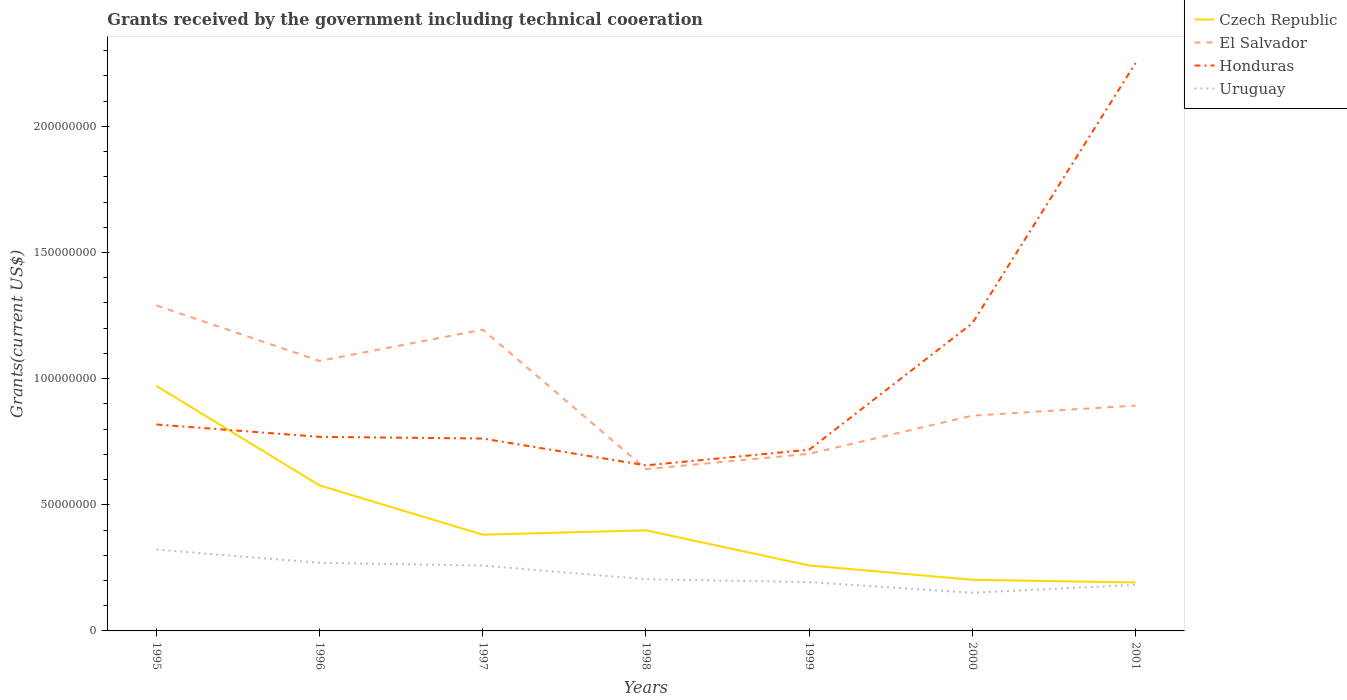How many different coloured lines are there?
Your answer should be compact. 4. Across all years, what is the maximum total grants received by the government in Honduras?
Ensure brevity in your answer.  6.56e+07. What is the total total grants received by the government in Honduras in the graph?
Keep it short and to the point. -6.20e+06. What is the difference between the highest and the second highest total grants received by the government in Czech Republic?
Make the answer very short. 7.79e+07. Is the total grants received by the government in El Salvador strictly greater than the total grants received by the government in Czech Republic over the years?
Give a very brief answer. No. How many years are there in the graph?
Offer a terse response. 7. What is the difference between two consecutive major ticks on the Y-axis?
Keep it short and to the point. 5.00e+07. Does the graph contain any zero values?
Provide a succinct answer. No. Where does the legend appear in the graph?
Provide a succinct answer. Top right. What is the title of the graph?
Provide a succinct answer. Grants received by the government including technical cooeration. Does "Haiti" appear as one of the legend labels in the graph?
Make the answer very short. No. What is the label or title of the X-axis?
Provide a succinct answer. Years. What is the label or title of the Y-axis?
Ensure brevity in your answer.  Grants(current US$). What is the Grants(current US$) in Czech Republic in 1995?
Your answer should be very brief. 9.71e+07. What is the Grants(current US$) in El Salvador in 1995?
Your answer should be compact. 1.29e+08. What is the Grants(current US$) in Honduras in 1995?
Provide a short and direct response. 8.18e+07. What is the Grants(current US$) in Uruguay in 1995?
Ensure brevity in your answer.  3.22e+07. What is the Grants(current US$) in Czech Republic in 1996?
Provide a short and direct response. 5.77e+07. What is the Grants(current US$) of El Salvador in 1996?
Keep it short and to the point. 1.07e+08. What is the Grants(current US$) in Honduras in 1996?
Provide a short and direct response. 7.69e+07. What is the Grants(current US$) in Uruguay in 1996?
Offer a very short reply. 2.70e+07. What is the Grants(current US$) of Czech Republic in 1997?
Your answer should be compact. 3.81e+07. What is the Grants(current US$) of El Salvador in 1997?
Offer a terse response. 1.19e+08. What is the Grants(current US$) in Honduras in 1997?
Provide a succinct answer. 7.63e+07. What is the Grants(current US$) in Uruguay in 1997?
Provide a short and direct response. 2.59e+07. What is the Grants(current US$) of Czech Republic in 1998?
Ensure brevity in your answer.  3.99e+07. What is the Grants(current US$) of El Salvador in 1998?
Provide a succinct answer. 6.41e+07. What is the Grants(current US$) of Honduras in 1998?
Your response must be concise. 6.56e+07. What is the Grants(current US$) in Uruguay in 1998?
Provide a short and direct response. 2.05e+07. What is the Grants(current US$) in Czech Republic in 1999?
Your response must be concise. 2.60e+07. What is the Grants(current US$) in El Salvador in 1999?
Keep it short and to the point. 7.02e+07. What is the Grants(current US$) in Honduras in 1999?
Offer a terse response. 7.18e+07. What is the Grants(current US$) of Uruguay in 1999?
Offer a very short reply. 1.94e+07. What is the Grants(current US$) in Czech Republic in 2000?
Make the answer very short. 2.03e+07. What is the Grants(current US$) in El Salvador in 2000?
Your answer should be very brief. 8.53e+07. What is the Grants(current US$) of Honduras in 2000?
Keep it short and to the point. 1.22e+08. What is the Grants(current US$) in Uruguay in 2000?
Your response must be concise. 1.51e+07. What is the Grants(current US$) of Czech Republic in 2001?
Make the answer very short. 1.92e+07. What is the Grants(current US$) of El Salvador in 2001?
Provide a short and direct response. 8.93e+07. What is the Grants(current US$) of Honduras in 2001?
Your answer should be compact. 2.25e+08. What is the Grants(current US$) of Uruguay in 2001?
Keep it short and to the point. 1.83e+07. Across all years, what is the maximum Grants(current US$) of Czech Republic?
Make the answer very short. 9.71e+07. Across all years, what is the maximum Grants(current US$) in El Salvador?
Provide a succinct answer. 1.29e+08. Across all years, what is the maximum Grants(current US$) in Honduras?
Ensure brevity in your answer.  2.25e+08. Across all years, what is the maximum Grants(current US$) in Uruguay?
Your answer should be compact. 3.22e+07. Across all years, what is the minimum Grants(current US$) in Czech Republic?
Provide a succinct answer. 1.92e+07. Across all years, what is the minimum Grants(current US$) in El Salvador?
Your answer should be compact. 6.41e+07. Across all years, what is the minimum Grants(current US$) of Honduras?
Keep it short and to the point. 6.56e+07. Across all years, what is the minimum Grants(current US$) in Uruguay?
Ensure brevity in your answer.  1.51e+07. What is the total Grants(current US$) of Czech Republic in the graph?
Your answer should be very brief. 2.98e+08. What is the total Grants(current US$) in El Salvador in the graph?
Make the answer very short. 6.64e+08. What is the total Grants(current US$) in Honduras in the graph?
Your response must be concise. 7.20e+08. What is the total Grants(current US$) in Uruguay in the graph?
Your answer should be compact. 1.58e+08. What is the difference between the Grants(current US$) in Czech Republic in 1995 and that in 1996?
Offer a terse response. 3.94e+07. What is the difference between the Grants(current US$) of El Salvador in 1995 and that in 1996?
Ensure brevity in your answer.  2.20e+07. What is the difference between the Grants(current US$) of Honduras in 1995 and that in 1996?
Offer a very short reply. 4.89e+06. What is the difference between the Grants(current US$) in Uruguay in 1995 and that in 1996?
Your answer should be very brief. 5.24e+06. What is the difference between the Grants(current US$) in Czech Republic in 1995 and that in 1997?
Give a very brief answer. 5.90e+07. What is the difference between the Grants(current US$) of El Salvador in 1995 and that in 1997?
Your answer should be compact. 9.61e+06. What is the difference between the Grants(current US$) in Honduras in 1995 and that in 1997?
Your answer should be compact. 5.56e+06. What is the difference between the Grants(current US$) of Uruguay in 1995 and that in 1997?
Your answer should be very brief. 6.32e+06. What is the difference between the Grants(current US$) of Czech Republic in 1995 and that in 1998?
Ensure brevity in your answer.  5.72e+07. What is the difference between the Grants(current US$) in El Salvador in 1995 and that in 1998?
Offer a terse response. 6.49e+07. What is the difference between the Grants(current US$) of Honduras in 1995 and that in 1998?
Offer a very short reply. 1.62e+07. What is the difference between the Grants(current US$) of Uruguay in 1995 and that in 1998?
Offer a terse response. 1.18e+07. What is the difference between the Grants(current US$) of Czech Republic in 1995 and that in 1999?
Your response must be concise. 7.12e+07. What is the difference between the Grants(current US$) of El Salvador in 1995 and that in 1999?
Your response must be concise. 5.88e+07. What is the difference between the Grants(current US$) of Honduras in 1995 and that in 1999?
Make the answer very short. 1.00e+07. What is the difference between the Grants(current US$) in Uruguay in 1995 and that in 1999?
Keep it short and to the point. 1.29e+07. What is the difference between the Grants(current US$) of Czech Republic in 1995 and that in 2000?
Keep it short and to the point. 7.68e+07. What is the difference between the Grants(current US$) of El Salvador in 1995 and that in 2000?
Keep it short and to the point. 4.37e+07. What is the difference between the Grants(current US$) of Honduras in 1995 and that in 2000?
Provide a succinct answer. -4.02e+07. What is the difference between the Grants(current US$) in Uruguay in 1995 and that in 2000?
Make the answer very short. 1.71e+07. What is the difference between the Grants(current US$) in Czech Republic in 1995 and that in 2001?
Offer a terse response. 7.79e+07. What is the difference between the Grants(current US$) in El Salvador in 1995 and that in 2001?
Make the answer very short. 3.97e+07. What is the difference between the Grants(current US$) of Honduras in 1995 and that in 2001?
Offer a very short reply. -1.43e+08. What is the difference between the Grants(current US$) in Uruguay in 1995 and that in 2001?
Give a very brief answer. 1.40e+07. What is the difference between the Grants(current US$) in Czech Republic in 1996 and that in 1997?
Keep it short and to the point. 1.95e+07. What is the difference between the Grants(current US$) in El Salvador in 1996 and that in 1997?
Ensure brevity in your answer.  -1.24e+07. What is the difference between the Grants(current US$) in Honduras in 1996 and that in 1997?
Provide a short and direct response. 6.70e+05. What is the difference between the Grants(current US$) in Uruguay in 1996 and that in 1997?
Keep it short and to the point. 1.08e+06. What is the difference between the Grants(current US$) in Czech Republic in 1996 and that in 1998?
Offer a terse response. 1.78e+07. What is the difference between the Grants(current US$) in El Salvador in 1996 and that in 1998?
Provide a succinct answer. 4.29e+07. What is the difference between the Grants(current US$) of Honduras in 1996 and that in 1998?
Provide a succinct answer. 1.13e+07. What is the difference between the Grants(current US$) in Uruguay in 1996 and that in 1998?
Give a very brief answer. 6.51e+06. What is the difference between the Grants(current US$) of Czech Republic in 1996 and that in 1999?
Your response must be concise. 3.17e+07. What is the difference between the Grants(current US$) of El Salvador in 1996 and that in 1999?
Provide a short and direct response. 3.68e+07. What is the difference between the Grants(current US$) in Honduras in 1996 and that in 1999?
Keep it short and to the point. 5.11e+06. What is the difference between the Grants(current US$) of Uruguay in 1996 and that in 1999?
Give a very brief answer. 7.65e+06. What is the difference between the Grants(current US$) of Czech Republic in 1996 and that in 2000?
Your response must be concise. 3.74e+07. What is the difference between the Grants(current US$) in El Salvador in 1996 and that in 2000?
Ensure brevity in your answer.  2.17e+07. What is the difference between the Grants(current US$) in Honduras in 1996 and that in 2000?
Provide a succinct answer. -4.50e+07. What is the difference between the Grants(current US$) in Uruguay in 1996 and that in 2000?
Ensure brevity in your answer.  1.19e+07. What is the difference between the Grants(current US$) in Czech Republic in 1996 and that in 2001?
Your answer should be compact. 3.85e+07. What is the difference between the Grants(current US$) of El Salvador in 1996 and that in 2001?
Make the answer very short. 1.77e+07. What is the difference between the Grants(current US$) in Honduras in 1996 and that in 2001?
Give a very brief answer. -1.48e+08. What is the difference between the Grants(current US$) of Uruguay in 1996 and that in 2001?
Provide a short and direct response. 8.73e+06. What is the difference between the Grants(current US$) of Czech Republic in 1997 and that in 1998?
Offer a very short reply. -1.74e+06. What is the difference between the Grants(current US$) of El Salvador in 1997 and that in 1998?
Provide a succinct answer. 5.53e+07. What is the difference between the Grants(current US$) in Honduras in 1997 and that in 1998?
Ensure brevity in your answer.  1.06e+07. What is the difference between the Grants(current US$) in Uruguay in 1997 and that in 1998?
Offer a terse response. 5.43e+06. What is the difference between the Grants(current US$) in Czech Republic in 1997 and that in 1999?
Offer a terse response. 1.22e+07. What is the difference between the Grants(current US$) of El Salvador in 1997 and that in 1999?
Keep it short and to the point. 4.92e+07. What is the difference between the Grants(current US$) in Honduras in 1997 and that in 1999?
Provide a short and direct response. 4.44e+06. What is the difference between the Grants(current US$) in Uruguay in 1997 and that in 1999?
Ensure brevity in your answer.  6.57e+06. What is the difference between the Grants(current US$) of Czech Republic in 1997 and that in 2000?
Ensure brevity in your answer.  1.79e+07. What is the difference between the Grants(current US$) in El Salvador in 1997 and that in 2000?
Offer a very short reply. 3.41e+07. What is the difference between the Grants(current US$) of Honduras in 1997 and that in 2000?
Provide a succinct answer. -4.57e+07. What is the difference between the Grants(current US$) of Uruguay in 1997 and that in 2000?
Give a very brief answer. 1.08e+07. What is the difference between the Grants(current US$) of Czech Republic in 1997 and that in 2001?
Ensure brevity in your answer.  1.89e+07. What is the difference between the Grants(current US$) of El Salvador in 1997 and that in 2001?
Offer a very short reply. 3.01e+07. What is the difference between the Grants(current US$) in Honduras in 1997 and that in 2001?
Offer a terse response. -1.49e+08. What is the difference between the Grants(current US$) in Uruguay in 1997 and that in 2001?
Your response must be concise. 7.65e+06. What is the difference between the Grants(current US$) of Czech Republic in 1998 and that in 1999?
Your answer should be very brief. 1.39e+07. What is the difference between the Grants(current US$) of El Salvador in 1998 and that in 1999?
Make the answer very short. -6.05e+06. What is the difference between the Grants(current US$) of Honduras in 1998 and that in 1999?
Your answer should be compact. -6.20e+06. What is the difference between the Grants(current US$) in Uruguay in 1998 and that in 1999?
Provide a succinct answer. 1.14e+06. What is the difference between the Grants(current US$) in Czech Republic in 1998 and that in 2000?
Your response must be concise. 1.96e+07. What is the difference between the Grants(current US$) of El Salvador in 1998 and that in 2000?
Your answer should be compact. -2.12e+07. What is the difference between the Grants(current US$) in Honduras in 1998 and that in 2000?
Give a very brief answer. -5.64e+07. What is the difference between the Grants(current US$) of Uruguay in 1998 and that in 2000?
Give a very brief answer. 5.36e+06. What is the difference between the Grants(current US$) of Czech Republic in 1998 and that in 2001?
Offer a terse response. 2.07e+07. What is the difference between the Grants(current US$) of El Salvador in 1998 and that in 2001?
Your response must be concise. -2.52e+07. What is the difference between the Grants(current US$) of Honduras in 1998 and that in 2001?
Your answer should be compact. -1.59e+08. What is the difference between the Grants(current US$) in Uruguay in 1998 and that in 2001?
Keep it short and to the point. 2.22e+06. What is the difference between the Grants(current US$) in Czech Republic in 1999 and that in 2000?
Your answer should be compact. 5.69e+06. What is the difference between the Grants(current US$) in El Salvador in 1999 and that in 2000?
Ensure brevity in your answer.  -1.51e+07. What is the difference between the Grants(current US$) of Honduras in 1999 and that in 2000?
Ensure brevity in your answer.  -5.02e+07. What is the difference between the Grants(current US$) in Uruguay in 1999 and that in 2000?
Keep it short and to the point. 4.22e+06. What is the difference between the Grants(current US$) of Czech Republic in 1999 and that in 2001?
Provide a short and direct response. 6.75e+06. What is the difference between the Grants(current US$) in El Salvador in 1999 and that in 2001?
Your answer should be compact. -1.91e+07. What is the difference between the Grants(current US$) in Honduras in 1999 and that in 2001?
Ensure brevity in your answer.  -1.53e+08. What is the difference between the Grants(current US$) in Uruguay in 1999 and that in 2001?
Provide a short and direct response. 1.08e+06. What is the difference between the Grants(current US$) in Czech Republic in 2000 and that in 2001?
Keep it short and to the point. 1.06e+06. What is the difference between the Grants(current US$) of Honduras in 2000 and that in 2001?
Ensure brevity in your answer.  -1.03e+08. What is the difference between the Grants(current US$) in Uruguay in 2000 and that in 2001?
Provide a succinct answer. -3.14e+06. What is the difference between the Grants(current US$) of Czech Republic in 1995 and the Grants(current US$) of El Salvador in 1996?
Ensure brevity in your answer.  -9.92e+06. What is the difference between the Grants(current US$) in Czech Republic in 1995 and the Grants(current US$) in Honduras in 1996?
Ensure brevity in your answer.  2.02e+07. What is the difference between the Grants(current US$) of Czech Republic in 1995 and the Grants(current US$) of Uruguay in 1996?
Your answer should be very brief. 7.01e+07. What is the difference between the Grants(current US$) of El Salvador in 1995 and the Grants(current US$) of Honduras in 1996?
Your answer should be very brief. 5.21e+07. What is the difference between the Grants(current US$) in El Salvador in 1995 and the Grants(current US$) in Uruguay in 1996?
Provide a succinct answer. 1.02e+08. What is the difference between the Grants(current US$) of Honduras in 1995 and the Grants(current US$) of Uruguay in 1996?
Your answer should be compact. 5.48e+07. What is the difference between the Grants(current US$) of Czech Republic in 1995 and the Grants(current US$) of El Salvador in 1997?
Your response must be concise. -2.23e+07. What is the difference between the Grants(current US$) of Czech Republic in 1995 and the Grants(current US$) of Honduras in 1997?
Ensure brevity in your answer.  2.08e+07. What is the difference between the Grants(current US$) in Czech Republic in 1995 and the Grants(current US$) in Uruguay in 1997?
Make the answer very short. 7.12e+07. What is the difference between the Grants(current US$) in El Salvador in 1995 and the Grants(current US$) in Honduras in 1997?
Your answer should be very brief. 5.28e+07. What is the difference between the Grants(current US$) in El Salvador in 1995 and the Grants(current US$) in Uruguay in 1997?
Provide a short and direct response. 1.03e+08. What is the difference between the Grants(current US$) of Honduras in 1995 and the Grants(current US$) of Uruguay in 1997?
Your response must be concise. 5.59e+07. What is the difference between the Grants(current US$) in Czech Republic in 1995 and the Grants(current US$) in El Salvador in 1998?
Provide a short and direct response. 3.30e+07. What is the difference between the Grants(current US$) of Czech Republic in 1995 and the Grants(current US$) of Honduras in 1998?
Make the answer very short. 3.15e+07. What is the difference between the Grants(current US$) in Czech Republic in 1995 and the Grants(current US$) in Uruguay in 1998?
Offer a terse response. 7.66e+07. What is the difference between the Grants(current US$) in El Salvador in 1995 and the Grants(current US$) in Honduras in 1998?
Your response must be concise. 6.34e+07. What is the difference between the Grants(current US$) of El Salvador in 1995 and the Grants(current US$) of Uruguay in 1998?
Make the answer very short. 1.09e+08. What is the difference between the Grants(current US$) in Honduras in 1995 and the Grants(current US$) in Uruguay in 1998?
Provide a succinct answer. 6.13e+07. What is the difference between the Grants(current US$) in Czech Republic in 1995 and the Grants(current US$) in El Salvador in 1999?
Keep it short and to the point. 2.69e+07. What is the difference between the Grants(current US$) of Czech Republic in 1995 and the Grants(current US$) of Honduras in 1999?
Provide a succinct answer. 2.53e+07. What is the difference between the Grants(current US$) of Czech Republic in 1995 and the Grants(current US$) of Uruguay in 1999?
Provide a succinct answer. 7.78e+07. What is the difference between the Grants(current US$) in El Salvador in 1995 and the Grants(current US$) in Honduras in 1999?
Offer a very short reply. 5.72e+07. What is the difference between the Grants(current US$) in El Salvador in 1995 and the Grants(current US$) in Uruguay in 1999?
Ensure brevity in your answer.  1.10e+08. What is the difference between the Grants(current US$) in Honduras in 1995 and the Grants(current US$) in Uruguay in 1999?
Your answer should be very brief. 6.25e+07. What is the difference between the Grants(current US$) of Czech Republic in 1995 and the Grants(current US$) of El Salvador in 2000?
Give a very brief answer. 1.18e+07. What is the difference between the Grants(current US$) in Czech Republic in 1995 and the Grants(current US$) in Honduras in 2000?
Offer a very short reply. -2.49e+07. What is the difference between the Grants(current US$) in Czech Republic in 1995 and the Grants(current US$) in Uruguay in 2000?
Ensure brevity in your answer.  8.20e+07. What is the difference between the Grants(current US$) in El Salvador in 1995 and the Grants(current US$) in Honduras in 2000?
Offer a very short reply. 7.06e+06. What is the difference between the Grants(current US$) in El Salvador in 1995 and the Grants(current US$) in Uruguay in 2000?
Ensure brevity in your answer.  1.14e+08. What is the difference between the Grants(current US$) in Honduras in 1995 and the Grants(current US$) in Uruguay in 2000?
Offer a very short reply. 6.67e+07. What is the difference between the Grants(current US$) of Czech Republic in 1995 and the Grants(current US$) of El Salvador in 2001?
Your answer should be very brief. 7.77e+06. What is the difference between the Grants(current US$) in Czech Republic in 1995 and the Grants(current US$) in Honduras in 2001?
Offer a terse response. -1.28e+08. What is the difference between the Grants(current US$) in Czech Republic in 1995 and the Grants(current US$) in Uruguay in 2001?
Provide a short and direct response. 7.88e+07. What is the difference between the Grants(current US$) of El Salvador in 1995 and the Grants(current US$) of Honduras in 2001?
Provide a short and direct response. -9.61e+07. What is the difference between the Grants(current US$) of El Salvador in 1995 and the Grants(current US$) of Uruguay in 2001?
Provide a succinct answer. 1.11e+08. What is the difference between the Grants(current US$) in Honduras in 1995 and the Grants(current US$) in Uruguay in 2001?
Your answer should be compact. 6.36e+07. What is the difference between the Grants(current US$) in Czech Republic in 1996 and the Grants(current US$) in El Salvador in 1997?
Keep it short and to the point. -6.17e+07. What is the difference between the Grants(current US$) in Czech Republic in 1996 and the Grants(current US$) in Honduras in 1997?
Keep it short and to the point. -1.86e+07. What is the difference between the Grants(current US$) of Czech Republic in 1996 and the Grants(current US$) of Uruguay in 1997?
Ensure brevity in your answer.  3.18e+07. What is the difference between the Grants(current US$) in El Salvador in 1996 and the Grants(current US$) in Honduras in 1997?
Your response must be concise. 3.08e+07. What is the difference between the Grants(current US$) in El Salvador in 1996 and the Grants(current US$) in Uruguay in 1997?
Keep it short and to the point. 8.11e+07. What is the difference between the Grants(current US$) of Honduras in 1996 and the Grants(current US$) of Uruguay in 1997?
Offer a terse response. 5.10e+07. What is the difference between the Grants(current US$) of Czech Republic in 1996 and the Grants(current US$) of El Salvador in 1998?
Your response must be concise. -6.46e+06. What is the difference between the Grants(current US$) of Czech Republic in 1996 and the Grants(current US$) of Honduras in 1998?
Ensure brevity in your answer.  -7.94e+06. What is the difference between the Grants(current US$) of Czech Republic in 1996 and the Grants(current US$) of Uruguay in 1998?
Your response must be concise. 3.72e+07. What is the difference between the Grants(current US$) of El Salvador in 1996 and the Grants(current US$) of Honduras in 1998?
Give a very brief answer. 4.14e+07. What is the difference between the Grants(current US$) of El Salvador in 1996 and the Grants(current US$) of Uruguay in 1998?
Provide a short and direct response. 8.65e+07. What is the difference between the Grants(current US$) of Honduras in 1996 and the Grants(current US$) of Uruguay in 1998?
Provide a short and direct response. 5.64e+07. What is the difference between the Grants(current US$) of Czech Republic in 1996 and the Grants(current US$) of El Salvador in 1999?
Your answer should be very brief. -1.25e+07. What is the difference between the Grants(current US$) in Czech Republic in 1996 and the Grants(current US$) in Honduras in 1999?
Give a very brief answer. -1.41e+07. What is the difference between the Grants(current US$) in Czech Republic in 1996 and the Grants(current US$) in Uruguay in 1999?
Make the answer very short. 3.83e+07. What is the difference between the Grants(current US$) in El Salvador in 1996 and the Grants(current US$) in Honduras in 1999?
Keep it short and to the point. 3.52e+07. What is the difference between the Grants(current US$) in El Salvador in 1996 and the Grants(current US$) in Uruguay in 1999?
Offer a terse response. 8.77e+07. What is the difference between the Grants(current US$) of Honduras in 1996 and the Grants(current US$) of Uruguay in 1999?
Your answer should be very brief. 5.76e+07. What is the difference between the Grants(current US$) of Czech Republic in 1996 and the Grants(current US$) of El Salvador in 2000?
Give a very brief answer. -2.76e+07. What is the difference between the Grants(current US$) of Czech Republic in 1996 and the Grants(current US$) of Honduras in 2000?
Keep it short and to the point. -6.43e+07. What is the difference between the Grants(current US$) of Czech Republic in 1996 and the Grants(current US$) of Uruguay in 2000?
Provide a short and direct response. 4.26e+07. What is the difference between the Grants(current US$) of El Salvador in 1996 and the Grants(current US$) of Honduras in 2000?
Give a very brief answer. -1.50e+07. What is the difference between the Grants(current US$) in El Salvador in 1996 and the Grants(current US$) in Uruguay in 2000?
Give a very brief answer. 9.19e+07. What is the difference between the Grants(current US$) in Honduras in 1996 and the Grants(current US$) in Uruguay in 2000?
Provide a short and direct response. 6.18e+07. What is the difference between the Grants(current US$) in Czech Republic in 1996 and the Grants(current US$) in El Salvador in 2001?
Offer a very short reply. -3.16e+07. What is the difference between the Grants(current US$) in Czech Republic in 1996 and the Grants(current US$) in Honduras in 2001?
Provide a short and direct response. -1.67e+08. What is the difference between the Grants(current US$) in Czech Republic in 1996 and the Grants(current US$) in Uruguay in 2001?
Give a very brief answer. 3.94e+07. What is the difference between the Grants(current US$) in El Salvador in 1996 and the Grants(current US$) in Honduras in 2001?
Your response must be concise. -1.18e+08. What is the difference between the Grants(current US$) of El Salvador in 1996 and the Grants(current US$) of Uruguay in 2001?
Your answer should be compact. 8.88e+07. What is the difference between the Grants(current US$) of Honduras in 1996 and the Grants(current US$) of Uruguay in 2001?
Your answer should be very brief. 5.87e+07. What is the difference between the Grants(current US$) in Czech Republic in 1997 and the Grants(current US$) in El Salvador in 1998?
Give a very brief answer. -2.60e+07. What is the difference between the Grants(current US$) of Czech Republic in 1997 and the Grants(current US$) of Honduras in 1998?
Make the answer very short. -2.75e+07. What is the difference between the Grants(current US$) of Czech Republic in 1997 and the Grants(current US$) of Uruguay in 1998?
Your answer should be compact. 1.76e+07. What is the difference between the Grants(current US$) of El Salvador in 1997 and the Grants(current US$) of Honduras in 1998?
Give a very brief answer. 5.38e+07. What is the difference between the Grants(current US$) in El Salvador in 1997 and the Grants(current US$) in Uruguay in 1998?
Give a very brief answer. 9.89e+07. What is the difference between the Grants(current US$) of Honduras in 1997 and the Grants(current US$) of Uruguay in 1998?
Provide a succinct answer. 5.58e+07. What is the difference between the Grants(current US$) of Czech Republic in 1997 and the Grants(current US$) of El Salvador in 1999?
Your answer should be very brief. -3.20e+07. What is the difference between the Grants(current US$) in Czech Republic in 1997 and the Grants(current US$) in Honduras in 1999?
Offer a terse response. -3.37e+07. What is the difference between the Grants(current US$) in Czech Republic in 1997 and the Grants(current US$) in Uruguay in 1999?
Your response must be concise. 1.88e+07. What is the difference between the Grants(current US$) of El Salvador in 1997 and the Grants(current US$) of Honduras in 1999?
Offer a terse response. 4.76e+07. What is the difference between the Grants(current US$) of El Salvador in 1997 and the Grants(current US$) of Uruguay in 1999?
Your answer should be very brief. 1.00e+08. What is the difference between the Grants(current US$) of Honduras in 1997 and the Grants(current US$) of Uruguay in 1999?
Make the answer very short. 5.69e+07. What is the difference between the Grants(current US$) in Czech Republic in 1997 and the Grants(current US$) in El Salvador in 2000?
Make the answer very short. -4.72e+07. What is the difference between the Grants(current US$) of Czech Republic in 1997 and the Grants(current US$) of Honduras in 2000?
Provide a short and direct response. -8.38e+07. What is the difference between the Grants(current US$) of Czech Republic in 1997 and the Grants(current US$) of Uruguay in 2000?
Ensure brevity in your answer.  2.30e+07. What is the difference between the Grants(current US$) in El Salvador in 1997 and the Grants(current US$) in Honduras in 2000?
Offer a very short reply. -2.55e+06. What is the difference between the Grants(current US$) in El Salvador in 1997 and the Grants(current US$) in Uruguay in 2000?
Keep it short and to the point. 1.04e+08. What is the difference between the Grants(current US$) of Honduras in 1997 and the Grants(current US$) of Uruguay in 2000?
Keep it short and to the point. 6.11e+07. What is the difference between the Grants(current US$) of Czech Republic in 1997 and the Grants(current US$) of El Salvador in 2001?
Your response must be concise. -5.12e+07. What is the difference between the Grants(current US$) of Czech Republic in 1997 and the Grants(current US$) of Honduras in 2001?
Make the answer very short. -1.87e+08. What is the difference between the Grants(current US$) in Czech Republic in 1997 and the Grants(current US$) in Uruguay in 2001?
Provide a short and direct response. 1.99e+07. What is the difference between the Grants(current US$) in El Salvador in 1997 and the Grants(current US$) in Honduras in 2001?
Your response must be concise. -1.06e+08. What is the difference between the Grants(current US$) of El Salvador in 1997 and the Grants(current US$) of Uruguay in 2001?
Offer a very short reply. 1.01e+08. What is the difference between the Grants(current US$) in Honduras in 1997 and the Grants(current US$) in Uruguay in 2001?
Offer a very short reply. 5.80e+07. What is the difference between the Grants(current US$) in Czech Republic in 1998 and the Grants(current US$) in El Salvador in 1999?
Make the answer very short. -3.03e+07. What is the difference between the Grants(current US$) in Czech Republic in 1998 and the Grants(current US$) in Honduras in 1999?
Your response must be concise. -3.19e+07. What is the difference between the Grants(current US$) of Czech Republic in 1998 and the Grants(current US$) of Uruguay in 1999?
Make the answer very short. 2.05e+07. What is the difference between the Grants(current US$) in El Salvador in 1998 and the Grants(current US$) in Honduras in 1999?
Your answer should be very brief. -7.68e+06. What is the difference between the Grants(current US$) of El Salvador in 1998 and the Grants(current US$) of Uruguay in 1999?
Provide a succinct answer. 4.48e+07. What is the difference between the Grants(current US$) of Honduras in 1998 and the Grants(current US$) of Uruguay in 1999?
Keep it short and to the point. 4.63e+07. What is the difference between the Grants(current US$) in Czech Republic in 1998 and the Grants(current US$) in El Salvador in 2000?
Provide a succinct answer. -4.54e+07. What is the difference between the Grants(current US$) of Czech Republic in 1998 and the Grants(current US$) of Honduras in 2000?
Make the answer very short. -8.21e+07. What is the difference between the Grants(current US$) in Czech Republic in 1998 and the Grants(current US$) in Uruguay in 2000?
Keep it short and to the point. 2.48e+07. What is the difference between the Grants(current US$) in El Salvador in 1998 and the Grants(current US$) in Honduras in 2000?
Give a very brief answer. -5.78e+07. What is the difference between the Grants(current US$) in El Salvador in 1998 and the Grants(current US$) in Uruguay in 2000?
Make the answer very short. 4.90e+07. What is the difference between the Grants(current US$) in Honduras in 1998 and the Grants(current US$) in Uruguay in 2000?
Keep it short and to the point. 5.05e+07. What is the difference between the Grants(current US$) of Czech Republic in 1998 and the Grants(current US$) of El Salvador in 2001?
Make the answer very short. -4.94e+07. What is the difference between the Grants(current US$) of Czech Republic in 1998 and the Grants(current US$) of Honduras in 2001?
Offer a very short reply. -1.85e+08. What is the difference between the Grants(current US$) in Czech Republic in 1998 and the Grants(current US$) in Uruguay in 2001?
Offer a terse response. 2.16e+07. What is the difference between the Grants(current US$) of El Salvador in 1998 and the Grants(current US$) of Honduras in 2001?
Make the answer very short. -1.61e+08. What is the difference between the Grants(current US$) of El Salvador in 1998 and the Grants(current US$) of Uruguay in 2001?
Give a very brief answer. 4.59e+07. What is the difference between the Grants(current US$) of Honduras in 1998 and the Grants(current US$) of Uruguay in 2001?
Offer a very short reply. 4.74e+07. What is the difference between the Grants(current US$) of Czech Republic in 1999 and the Grants(current US$) of El Salvador in 2000?
Your response must be concise. -5.94e+07. What is the difference between the Grants(current US$) of Czech Republic in 1999 and the Grants(current US$) of Honduras in 2000?
Provide a short and direct response. -9.60e+07. What is the difference between the Grants(current US$) in Czech Republic in 1999 and the Grants(current US$) in Uruguay in 2000?
Keep it short and to the point. 1.08e+07. What is the difference between the Grants(current US$) of El Salvador in 1999 and the Grants(current US$) of Honduras in 2000?
Give a very brief answer. -5.18e+07. What is the difference between the Grants(current US$) in El Salvador in 1999 and the Grants(current US$) in Uruguay in 2000?
Provide a succinct answer. 5.51e+07. What is the difference between the Grants(current US$) of Honduras in 1999 and the Grants(current US$) of Uruguay in 2000?
Your response must be concise. 5.67e+07. What is the difference between the Grants(current US$) of Czech Republic in 1999 and the Grants(current US$) of El Salvador in 2001?
Provide a succinct answer. -6.34e+07. What is the difference between the Grants(current US$) in Czech Republic in 1999 and the Grants(current US$) in Honduras in 2001?
Your answer should be very brief. -1.99e+08. What is the difference between the Grants(current US$) in Czech Republic in 1999 and the Grants(current US$) in Uruguay in 2001?
Provide a succinct answer. 7.68e+06. What is the difference between the Grants(current US$) in El Salvador in 1999 and the Grants(current US$) in Honduras in 2001?
Offer a terse response. -1.55e+08. What is the difference between the Grants(current US$) in El Salvador in 1999 and the Grants(current US$) in Uruguay in 2001?
Provide a short and direct response. 5.19e+07. What is the difference between the Grants(current US$) in Honduras in 1999 and the Grants(current US$) in Uruguay in 2001?
Keep it short and to the point. 5.36e+07. What is the difference between the Grants(current US$) in Czech Republic in 2000 and the Grants(current US$) in El Salvador in 2001?
Ensure brevity in your answer.  -6.91e+07. What is the difference between the Grants(current US$) of Czech Republic in 2000 and the Grants(current US$) of Honduras in 2001?
Give a very brief answer. -2.05e+08. What is the difference between the Grants(current US$) of Czech Republic in 2000 and the Grants(current US$) of Uruguay in 2001?
Provide a short and direct response. 1.99e+06. What is the difference between the Grants(current US$) in El Salvador in 2000 and the Grants(current US$) in Honduras in 2001?
Offer a terse response. -1.40e+08. What is the difference between the Grants(current US$) of El Salvador in 2000 and the Grants(current US$) of Uruguay in 2001?
Provide a short and direct response. 6.71e+07. What is the difference between the Grants(current US$) in Honduras in 2000 and the Grants(current US$) in Uruguay in 2001?
Your answer should be compact. 1.04e+08. What is the average Grants(current US$) in Czech Republic per year?
Your answer should be very brief. 4.26e+07. What is the average Grants(current US$) in El Salvador per year?
Provide a succinct answer. 9.49e+07. What is the average Grants(current US$) of Honduras per year?
Provide a short and direct response. 1.03e+08. What is the average Grants(current US$) of Uruguay per year?
Your answer should be compact. 2.26e+07. In the year 1995, what is the difference between the Grants(current US$) in Czech Republic and Grants(current US$) in El Salvador?
Your answer should be very brief. -3.19e+07. In the year 1995, what is the difference between the Grants(current US$) of Czech Republic and Grants(current US$) of Honduras?
Your answer should be compact. 1.53e+07. In the year 1995, what is the difference between the Grants(current US$) in Czech Republic and Grants(current US$) in Uruguay?
Keep it short and to the point. 6.49e+07. In the year 1995, what is the difference between the Grants(current US$) of El Salvador and Grants(current US$) of Honduras?
Make the answer very short. 4.72e+07. In the year 1995, what is the difference between the Grants(current US$) in El Salvador and Grants(current US$) in Uruguay?
Give a very brief answer. 9.68e+07. In the year 1995, what is the difference between the Grants(current US$) in Honduras and Grants(current US$) in Uruguay?
Ensure brevity in your answer.  4.96e+07. In the year 1996, what is the difference between the Grants(current US$) of Czech Republic and Grants(current US$) of El Salvador?
Ensure brevity in your answer.  -4.93e+07. In the year 1996, what is the difference between the Grants(current US$) of Czech Republic and Grants(current US$) of Honduras?
Provide a succinct answer. -1.92e+07. In the year 1996, what is the difference between the Grants(current US$) in Czech Republic and Grants(current US$) in Uruguay?
Provide a short and direct response. 3.07e+07. In the year 1996, what is the difference between the Grants(current US$) in El Salvador and Grants(current US$) in Honduras?
Make the answer very short. 3.01e+07. In the year 1996, what is the difference between the Grants(current US$) in El Salvador and Grants(current US$) in Uruguay?
Offer a very short reply. 8.00e+07. In the year 1996, what is the difference between the Grants(current US$) in Honduras and Grants(current US$) in Uruguay?
Give a very brief answer. 4.99e+07. In the year 1997, what is the difference between the Grants(current US$) of Czech Republic and Grants(current US$) of El Salvador?
Make the answer very short. -8.13e+07. In the year 1997, what is the difference between the Grants(current US$) in Czech Republic and Grants(current US$) in Honduras?
Your answer should be very brief. -3.81e+07. In the year 1997, what is the difference between the Grants(current US$) of Czech Republic and Grants(current US$) of Uruguay?
Give a very brief answer. 1.22e+07. In the year 1997, what is the difference between the Grants(current US$) in El Salvador and Grants(current US$) in Honduras?
Give a very brief answer. 4.32e+07. In the year 1997, what is the difference between the Grants(current US$) in El Salvador and Grants(current US$) in Uruguay?
Provide a short and direct response. 9.35e+07. In the year 1997, what is the difference between the Grants(current US$) in Honduras and Grants(current US$) in Uruguay?
Make the answer very short. 5.03e+07. In the year 1998, what is the difference between the Grants(current US$) in Czech Republic and Grants(current US$) in El Salvador?
Your response must be concise. -2.43e+07. In the year 1998, what is the difference between the Grants(current US$) of Czech Republic and Grants(current US$) of Honduras?
Offer a terse response. -2.57e+07. In the year 1998, what is the difference between the Grants(current US$) in Czech Republic and Grants(current US$) in Uruguay?
Give a very brief answer. 1.94e+07. In the year 1998, what is the difference between the Grants(current US$) in El Salvador and Grants(current US$) in Honduras?
Your answer should be very brief. -1.48e+06. In the year 1998, what is the difference between the Grants(current US$) in El Salvador and Grants(current US$) in Uruguay?
Provide a succinct answer. 4.36e+07. In the year 1998, what is the difference between the Grants(current US$) of Honduras and Grants(current US$) of Uruguay?
Keep it short and to the point. 4.51e+07. In the year 1999, what is the difference between the Grants(current US$) in Czech Republic and Grants(current US$) in El Salvador?
Provide a succinct answer. -4.42e+07. In the year 1999, what is the difference between the Grants(current US$) in Czech Republic and Grants(current US$) in Honduras?
Your answer should be very brief. -4.59e+07. In the year 1999, what is the difference between the Grants(current US$) in Czech Republic and Grants(current US$) in Uruguay?
Offer a very short reply. 6.60e+06. In the year 1999, what is the difference between the Grants(current US$) in El Salvador and Grants(current US$) in Honduras?
Keep it short and to the point. -1.63e+06. In the year 1999, what is the difference between the Grants(current US$) of El Salvador and Grants(current US$) of Uruguay?
Your answer should be very brief. 5.08e+07. In the year 1999, what is the difference between the Grants(current US$) in Honduras and Grants(current US$) in Uruguay?
Make the answer very short. 5.25e+07. In the year 2000, what is the difference between the Grants(current US$) of Czech Republic and Grants(current US$) of El Salvador?
Your answer should be compact. -6.51e+07. In the year 2000, what is the difference between the Grants(current US$) in Czech Republic and Grants(current US$) in Honduras?
Your response must be concise. -1.02e+08. In the year 2000, what is the difference between the Grants(current US$) of Czech Republic and Grants(current US$) of Uruguay?
Your answer should be very brief. 5.13e+06. In the year 2000, what is the difference between the Grants(current US$) in El Salvador and Grants(current US$) in Honduras?
Keep it short and to the point. -3.66e+07. In the year 2000, what is the difference between the Grants(current US$) of El Salvador and Grants(current US$) of Uruguay?
Your answer should be compact. 7.02e+07. In the year 2000, what is the difference between the Grants(current US$) in Honduras and Grants(current US$) in Uruguay?
Offer a very short reply. 1.07e+08. In the year 2001, what is the difference between the Grants(current US$) of Czech Republic and Grants(current US$) of El Salvador?
Keep it short and to the point. -7.01e+07. In the year 2001, what is the difference between the Grants(current US$) in Czech Republic and Grants(current US$) in Honduras?
Ensure brevity in your answer.  -2.06e+08. In the year 2001, what is the difference between the Grants(current US$) in Czech Republic and Grants(current US$) in Uruguay?
Your response must be concise. 9.30e+05. In the year 2001, what is the difference between the Grants(current US$) of El Salvador and Grants(current US$) of Honduras?
Your answer should be compact. -1.36e+08. In the year 2001, what is the difference between the Grants(current US$) in El Salvador and Grants(current US$) in Uruguay?
Your answer should be very brief. 7.11e+07. In the year 2001, what is the difference between the Grants(current US$) in Honduras and Grants(current US$) in Uruguay?
Offer a terse response. 2.07e+08. What is the ratio of the Grants(current US$) in Czech Republic in 1995 to that in 1996?
Make the answer very short. 1.68. What is the ratio of the Grants(current US$) of El Salvador in 1995 to that in 1996?
Your answer should be compact. 1.21. What is the ratio of the Grants(current US$) in Honduras in 1995 to that in 1996?
Provide a succinct answer. 1.06. What is the ratio of the Grants(current US$) in Uruguay in 1995 to that in 1996?
Give a very brief answer. 1.19. What is the ratio of the Grants(current US$) in Czech Republic in 1995 to that in 1997?
Ensure brevity in your answer.  2.55. What is the ratio of the Grants(current US$) of El Salvador in 1995 to that in 1997?
Your response must be concise. 1.08. What is the ratio of the Grants(current US$) of Honduras in 1995 to that in 1997?
Your response must be concise. 1.07. What is the ratio of the Grants(current US$) in Uruguay in 1995 to that in 1997?
Your answer should be compact. 1.24. What is the ratio of the Grants(current US$) in Czech Republic in 1995 to that in 1998?
Ensure brevity in your answer.  2.43. What is the ratio of the Grants(current US$) of El Salvador in 1995 to that in 1998?
Give a very brief answer. 2.01. What is the ratio of the Grants(current US$) of Honduras in 1995 to that in 1998?
Provide a succinct answer. 1.25. What is the ratio of the Grants(current US$) of Uruguay in 1995 to that in 1998?
Provide a short and direct response. 1.57. What is the ratio of the Grants(current US$) in Czech Republic in 1995 to that in 1999?
Your response must be concise. 3.74. What is the ratio of the Grants(current US$) of El Salvador in 1995 to that in 1999?
Give a very brief answer. 1.84. What is the ratio of the Grants(current US$) in Honduras in 1995 to that in 1999?
Offer a very short reply. 1.14. What is the ratio of the Grants(current US$) of Uruguay in 1995 to that in 1999?
Keep it short and to the point. 1.67. What is the ratio of the Grants(current US$) in Czech Republic in 1995 to that in 2000?
Give a very brief answer. 4.79. What is the ratio of the Grants(current US$) of El Salvador in 1995 to that in 2000?
Offer a terse response. 1.51. What is the ratio of the Grants(current US$) of Honduras in 1995 to that in 2000?
Offer a very short reply. 0.67. What is the ratio of the Grants(current US$) in Uruguay in 1995 to that in 2000?
Offer a terse response. 2.13. What is the ratio of the Grants(current US$) in Czech Republic in 1995 to that in 2001?
Your answer should be compact. 5.06. What is the ratio of the Grants(current US$) of El Salvador in 1995 to that in 2001?
Give a very brief answer. 1.44. What is the ratio of the Grants(current US$) of Honduras in 1995 to that in 2001?
Keep it short and to the point. 0.36. What is the ratio of the Grants(current US$) in Uruguay in 1995 to that in 2001?
Provide a succinct answer. 1.76. What is the ratio of the Grants(current US$) of Czech Republic in 1996 to that in 1997?
Make the answer very short. 1.51. What is the ratio of the Grants(current US$) in El Salvador in 1996 to that in 1997?
Offer a very short reply. 0.9. What is the ratio of the Grants(current US$) of Honduras in 1996 to that in 1997?
Your response must be concise. 1.01. What is the ratio of the Grants(current US$) in Uruguay in 1996 to that in 1997?
Your answer should be compact. 1.04. What is the ratio of the Grants(current US$) of Czech Republic in 1996 to that in 1998?
Your answer should be very brief. 1.45. What is the ratio of the Grants(current US$) of El Salvador in 1996 to that in 1998?
Your answer should be compact. 1.67. What is the ratio of the Grants(current US$) of Honduras in 1996 to that in 1998?
Offer a very short reply. 1.17. What is the ratio of the Grants(current US$) of Uruguay in 1996 to that in 1998?
Offer a terse response. 1.32. What is the ratio of the Grants(current US$) of Czech Republic in 1996 to that in 1999?
Your answer should be very brief. 2.22. What is the ratio of the Grants(current US$) of El Salvador in 1996 to that in 1999?
Provide a succinct answer. 1.52. What is the ratio of the Grants(current US$) in Honduras in 1996 to that in 1999?
Give a very brief answer. 1.07. What is the ratio of the Grants(current US$) of Uruguay in 1996 to that in 1999?
Give a very brief answer. 1.4. What is the ratio of the Grants(current US$) in Czech Republic in 1996 to that in 2000?
Your response must be concise. 2.85. What is the ratio of the Grants(current US$) in El Salvador in 1996 to that in 2000?
Offer a very short reply. 1.25. What is the ratio of the Grants(current US$) in Honduras in 1996 to that in 2000?
Offer a terse response. 0.63. What is the ratio of the Grants(current US$) in Uruguay in 1996 to that in 2000?
Your response must be concise. 1.78. What is the ratio of the Grants(current US$) of Czech Republic in 1996 to that in 2001?
Ensure brevity in your answer.  3. What is the ratio of the Grants(current US$) of El Salvador in 1996 to that in 2001?
Your response must be concise. 1.2. What is the ratio of the Grants(current US$) of Honduras in 1996 to that in 2001?
Give a very brief answer. 0.34. What is the ratio of the Grants(current US$) in Uruguay in 1996 to that in 2001?
Ensure brevity in your answer.  1.48. What is the ratio of the Grants(current US$) in Czech Republic in 1997 to that in 1998?
Provide a succinct answer. 0.96. What is the ratio of the Grants(current US$) of El Salvador in 1997 to that in 1998?
Offer a terse response. 1.86. What is the ratio of the Grants(current US$) of Honduras in 1997 to that in 1998?
Ensure brevity in your answer.  1.16. What is the ratio of the Grants(current US$) of Uruguay in 1997 to that in 1998?
Provide a short and direct response. 1.26. What is the ratio of the Grants(current US$) in Czech Republic in 1997 to that in 1999?
Your answer should be compact. 1.47. What is the ratio of the Grants(current US$) in El Salvador in 1997 to that in 1999?
Provide a succinct answer. 1.7. What is the ratio of the Grants(current US$) of Honduras in 1997 to that in 1999?
Offer a terse response. 1.06. What is the ratio of the Grants(current US$) in Uruguay in 1997 to that in 1999?
Your answer should be compact. 1.34. What is the ratio of the Grants(current US$) in Czech Republic in 1997 to that in 2000?
Offer a terse response. 1.88. What is the ratio of the Grants(current US$) in El Salvador in 1997 to that in 2000?
Your response must be concise. 1.4. What is the ratio of the Grants(current US$) in Honduras in 1997 to that in 2000?
Keep it short and to the point. 0.63. What is the ratio of the Grants(current US$) of Uruguay in 1997 to that in 2000?
Offer a very short reply. 1.71. What is the ratio of the Grants(current US$) in Czech Republic in 1997 to that in 2001?
Ensure brevity in your answer.  1.99. What is the ratio of the Grants(current US$) of El Salvador in 1997 to that in 2001?
Keep it short and to the point. 1.34. What is the ratio of the Grants(current US$) of Honduras in 1997 to that in 2001?
Ensure brevity in your answer.  0.34. What is the ratio of the Grants(current US$) of Uruguay in 1997 to that in 2001?
Offer a very short reply. 1.42. What is the ratio of the Grants(current US$) of Czech Republic in 1998 to that in 1999?
Provide a succinct answer. 1.54. What is the ratio of the Grants(current US$) in El Salvador in 1998 to that in 1999?
Offer a terse response. 0.91. What is the ratio of the Grants(current US$) in Honduras in 1998 to that in 1999?
Your answer should be very brief. 0.91. What is the ratio of the Grants(current US$) in Uruguay in 1998 to that in 1999?
Your answer should be compact. 1.06. What is the ratio of the Grants(current US$) of Czech Republic in 1998 to that in 2000?
Provide a short and direct response. 1.97. What is the ratio of the Grants(current US$) in El Salvador in 1998 to that in 2000?
Give a very brief answer. 0.75. What is the ratio of the Grants(current US$) in Honduras in 1998 to that in 2000?
Offer a terse response. 0.54. What is the ratio of the Grants(current US$) of Uruguay in 1998 to that in 2000?
Your response must be concise. 1.35. What is the ratio of the Grants(current US$) in Czech Republic in 1998 to that in 2001?
Give a very brief answer. 2.08. What is the ratio of the Grants(current US$) of El Salvador in 1998 to that in 2001?
Your answer should be very brief. 0.72. What is the ratio of the Grants(current US$) in Honduras in 1998 to that in 2001?
Offer a very short reply. 0.29. What is the ratio of the Grants(current US$) of Uruguay in 1998 to that in 2001?
Keep it short and to the point. 1.12. What is the ratio of the Grants(current US$) of Czech Republic in 1999 to that in 2000?
Your response must be concise. 1.28. What is the ratio of the Grants(current US$) of El Salvador in 1999 to that in 2000?
Your answer should be very brief. 0.82. What is the ratio of the Grants(current US$) in Honduras in 1999 to that in 2000?
Ensure brevity in your answer.  0.59. What is the ratio of the Grants(current US$) of Uruguay in 1999 to that in 2000?
Offer a terse response. 1.28. What is the ratio of the Grants(current US$) of Czech Republic in 1999 to that in 2001?
Keep it short and to the point. 1.35. What is the ratio of the Grants(current US$) in El Salvador in 1999 to that in 2001?
Your answer should be very brief. 0.79. What is the ratio of the Grants(current US$) of Honduras in 1999 to that in 2001?
Ensure brevity in your answer.  0.32. What is the ratio of the Grants(current US$) of Uruguay in 1999 to that in 2001?
Make the answer very short. 1.06. What is the ratio of the Grants(current US$) in Czech Republic in 2000 to that in 2001?
Offer a very short reply. 1.06. What is the ratio of the Grants(current US$) in El Salvador in 2000 to that in 2001?
Your response must be concise. 0.96. What is the ratio of the Grants(current US$) in Honduras in 2000 to that in 2001?
Make the answer very short. 0.54. What is the ratio of the Grants(current US$) of Uruguay in 2000 to that in 2001?
Provide a succinct answer. 0.83. What is the difference between the highest and the second highest Grants(current US$) of Czech Republic?
Give a very brief answer. 3.94e+07. What is the difference between the highest and the second highest Grants(current US$) of El Salvador?
Offer a terse response. 9.61e+06. What is the difference between the highest and the second highest Grants(current US$) in Honduras?
Provide a short and direct response. 1.03e+08. What is the difference between the highest and the second highest Grants(current US$) of Uruguay?
Provide a succinct answer. 5.24e+06. What is the difference between the highest and the lowest Grants(current US$) of Czech Republic?
Offer a very short reply. 7.79e+07. What is the difference between the highest and the lowest Grants(current US$) in El Salvador?
Your response must be concise. 6.49e+07. What is the difference between the highest and the lowest Grants(current US$) in Honduras?
Your response must be concise. 1.59e+08. What is the difference between the highest and the lowest Grants(current US$) of Uruguay?
Your answer should be compact. 1.71e+07. 